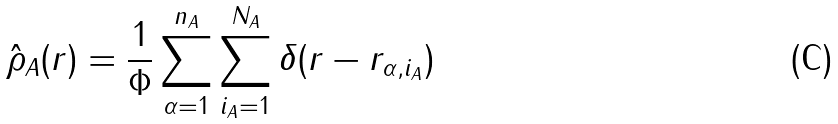Convert formula to latex. <formula><loc_0><loc_0><loc_500><loc_500>\hat { \rho } _ { A } ( r ) = \frac { 1 } { \Phi } \sum _ { \alpha = 1 } ^ { n _ { A } } \sum _ { i _ { A } = 1 } ^ { N _ { A } } \delta ( r - r _ { \alpha , i _ { A } } )</formula> 